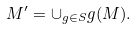Convert formula to latex. <formula><loc_0><loc_0><loc_500><loc_500>M ^ { \prime } = \cup _ { g \in S } g ( M ) .</formula> 